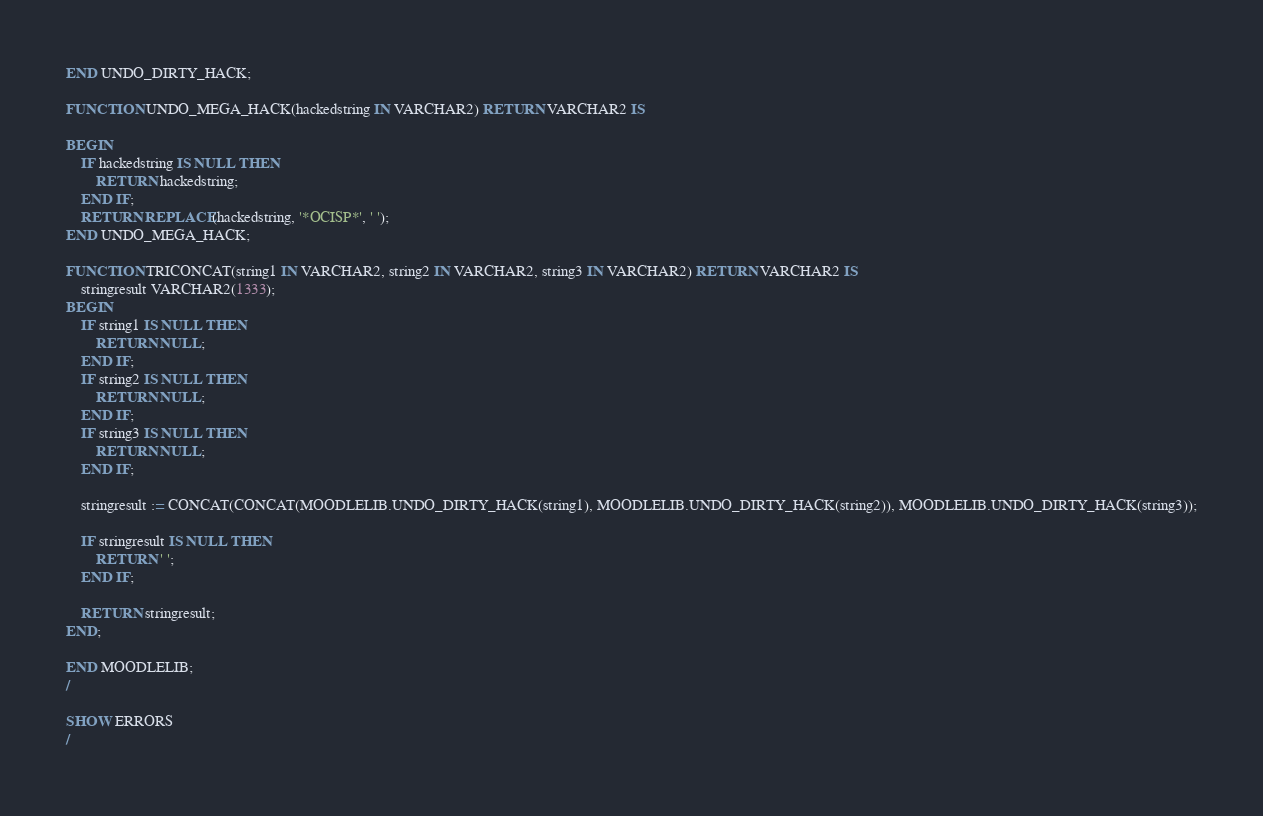<code> <loc_0><loc_0><loc_500><loc_500><_SQL_>END UNDO_DIRTY_HACK;

FUNCTION UNDO_MEGA_HACK(hackedstring IN VARCHAR2) RETURN VARCHAR2 IS

BEGIN
    IF hackedstring IS NULL THEN
        RETURN hackedstring;
    END IF;
    RETURN REPLACE(hackedstring, '*OCISP*', ' ');
END UNDO_MEGA_HACK;

FUNCTION TRICONCAT(string1 IN VARCHAR2, string2 IN VARCHAR2, string3 IN VARCHAR2) RETURN VARCHAR2 IS
    stringresult VARCHAR2(1333);
BEGIN
    IF string1 IS NULL THEN
        RETURN NULL;
    END IF;
    IF string2 IS NULL THEN
        RETURN NULL;
    END IF;
    IF string3 IS NULL THEN
        RETURN NULL;
    END IF;

    stringresult := CONCAT(CONCAT(MOODLELIB.UNDO_DIRTY_HACK(string1), MOODLELIB.UNDO_DIRTY_HACK(string2)), MOODLELIB.UNDO_DIRTY_HACK(string3));

    IF stringresult IS NULL THEN
        RETURN ' ';
    END IF;

    RETURN stringresult;
END;

END MOODLELIB;
/

SHOW ERRORS
/
</code> 